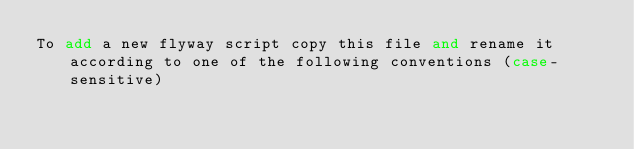<code> <loc_0><loc_0><loc_500><loc_500><_SQL_>To add a new flyway script copy this file and rename it according to one of the following conventions (case-sensitive)
</code> 